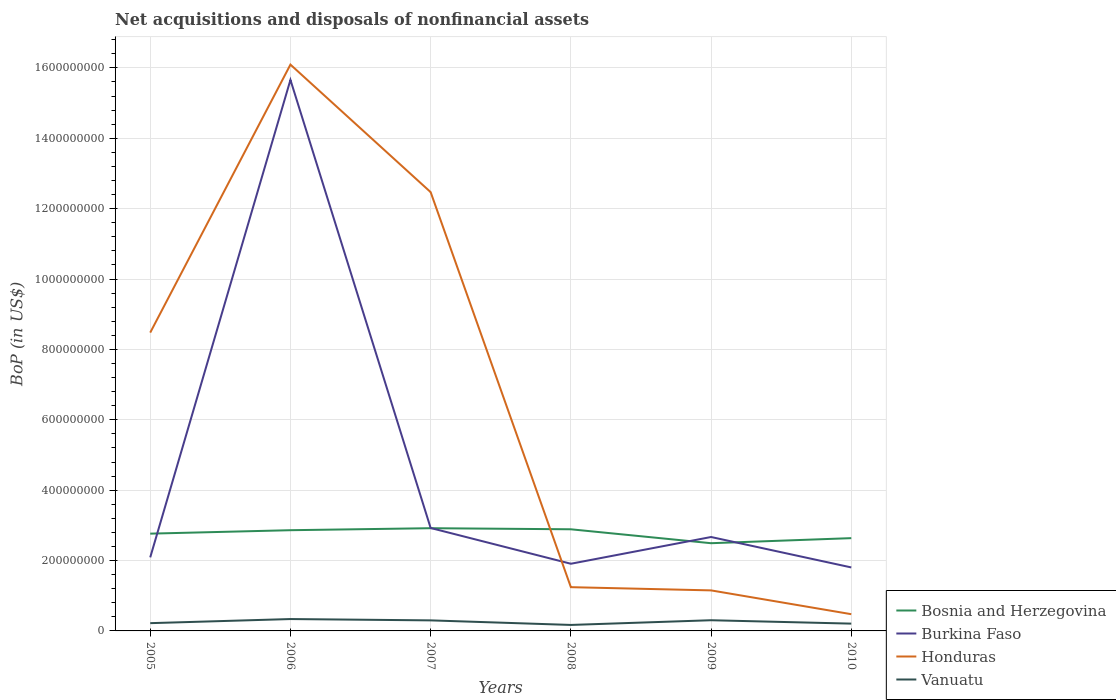How many different coloured lines are there?
Ensure brevity in your answer.  4. Across all years, what is the maximum Balance of Payments in Honduras?
Ensure brevity in your answer.  4.76e+07. What is the total Balance of Payments in Vanuatu in the graph?
Keep it short and to the point. 9.23e+06. What is the difference between the highest and the second highest Balance of Payments in Vanuatu?
Your answer should be very brief. 1.67e+07. What is the difference between the highest and the lowest Balance of Payments in Vanuatu?
Your response must be concise. 3. How many lines are there?
Ensure brevity in your answer.  4. How many years are there in the graph?
Give a very brief answer. 6. Does the graph contain grids?
Keep it short and to the point. Yes. Where does the legend appear in the graph?
Offer a terse response. Bottom right. What is the title of the graph?
Give a very brief answer. Net acquisitions and disposals of nonfinancial assets. Does "Middle East & North Africa (all income levels)" appear as one of the legend labels in the graph?
Ensure brevity in your answer.  No. What is the label or title of the X-axis?
Ensure brevity in your answer.  Years. What is the label or title of the Y-axis?
Offer a terse response. BoP (in US$). What is the BoP (in US$) in Bosnia and Herzegovina in 2005?
Your answer should be compact. 2.76e+08. What is the BoP (in US$) of Burkina Faso in 2005?
Your answer should be compact. 2.09e+08. What is the BoP (in US$) in Honduras in 2005?
Your answer should be compact. 8.48e+08. What is the BoP (in US$) of Vanuatu in 2005?
Make the answer very short. 2.21e+07. What is the BoP (in US$) in Bosnia and Herzegovina in 2006?
Ensure brevity in your answer.  2.86e+08. What is the BoP (in US$) of Burkina Faso in 2006?
Your answer should be very brief. 1.57e+09. What is the BoP (in US$) in Honduras in 2006?
Ensure brevity in your answer.  1.61e+09. What is the BoP (in US$) in Vanuatu in 2006?
Provide a succinct answer. 3.37e+07. What is the BoP (in US$) in Bosnia and Herzegovina in 2007?
Keep it short and to the point. 2.92e+08. What is the BoP (in US$) in Burkina Faso in 2007?
Give a very brief answer. 2.92e+08. What is the BoP (in US$) in Honduras in 2007?
Give a very brief answer. 1.25e+09. What is the BoP (in US$) of Vanuatu in 2007?
Ensure brevity in your answer.  3.00e+07. What is the BoP (in US$) of Bosnia and Herzegovina in 2008?
Make the answer very short. 2.89e+08. What is the BoP (in US$) of Burkina Faso in 2008?
Ensure brevity in your answer.  1.91e+08. What is the BoP (in US$) of Honduras in 2008?
Ensure brevity in your answer.  1.24e+08. What is the BoP (in US$) of Vanuatu in 2008?
Make the answer very short. 1.70e+07. What is the BoP (in US$) in Bosnia and Herzegovina in 2009?
Your answer should be very brief. 2.49e+08. What is the BoP (in US$) of Burkina Faso in 2009?
Provide a short and direct response. 2.67e+08. What is the BoP (in US$) of Honduras in 2009?
Offer a terse response. 1.15e+08. What is the BoP (in US$) of Vanuatu in 2009?
Your response must be concise. 3.04e+07. What is the BoP (in US$) in Bosnia and Herzegovina in 2010?
Keep it short and to the point. 2.64e+08. What is the BoP (in US$) of Burkina Faso in 2010?
Give a very brief answer. 1.80e+08. What is the BoP (in US$) in Honduras in 2010?
Give a very brief answer. 4.76e+07. What is the BoP (in US$) in Vanuatu in 2010?
Your answer should be very brief. 2.07e+07. Across all years, what is the maximum BoP (in US$) of Bosnia and Herzegovina?
Give a very brief answer. 2.92e+08. Across all years, what is the maximum BoP (in US$) of Burkina Faso?
Provide a short and direct response. 1.57e+09. Across all years, what is the maximum BoP (in US$) in Honduras?
Offer a very short reply. 1.61e+09. Across all years, what is the maximum BoP (in US$) of Vanuatu?
Offer a very short reply. 3.37e+07. Across all years, what is the minimum BoP (in US$) of Bosnia and Herzegovina?
Provide a short and direct response. 2.49e+08. Across all years, what is the minimum BoP (in US$) in Burkina Faso?
Ensure brevity in your answer.  1.80e+08. Across all years, what is the minimum BoP (in US$) of Honduras?
Keep it short and to the point. 4.76e+07. Across all years, what is the minimum BoP (in US$) of Vanuatu?
Ensure brevity in your answer.  1.70e+07. What is the total BoP (in US$) in Bosnia and Herzegovina in the graph?
Keep it short and to the point. 1.66e+09. What is the total BoP (in US$) in Burkina Faso in the graph?
Your response must be concise. 2.71e+09. What is the total BoP (in US$) in Honduras in the graph?
Your response must be concise. 3.99e+09. What is the total BoP (in US$) of Vanuatu in the graph?
Your response must be concise. 1.54e+08. What is the difference between the BoP (in US$) in Bosnia and Herzegovina in 2005 and that in 2006?
Make the answer very short. -9.77e+06. What is the difference between the BoP (in US$) in Burkina Faso in 2005 and that in 2006?
Give a very brief answer. -1.36e+09. What is the difference between the BoP (in US$) in Honduras in 2005 and that in 2006?
Your answer should be compact. -7.62e+08. What is the difference between the BoP (in US$) of Vanuatu in 2005 and that in 2006?
Give a very brief answer. -1.17e+07. What is the difference between the BoP (in US$) of Bosnia and Herzegovina in 2005 and that in 2007?
Provide a succinct answer. -1.54e+07. What is the difference between the BoP (in US$) in Burkina Faso in 2005 and that in 2007?
Your answer should be very brief. -8.35e+07. What is the difference between the BoP (in US$) of Honduras in 2005 and that in 2007?
Offer a very short reply. -3.99e+08. What is the difference between the BoP (in US$) of Vanuatu in 2005 and that in 2007?
Your answer should be very brief. -7.89e+06. What is the difference between the BoP (in US$) of Bosnia and Herzegovina in 2005 and that in 2008?
Offer a very short reply. -1.24e+07. What is the difference between the BoP (in US$) in Burkina Faso in 2005 and that in 2008?
Ensure brevity in your answer.  1.81e+07. What is the difference between the BoP (in US$) in Honduras in 2005 and that in 2008?
Provide a short and direct response. 7.23e+08. What is the difference between the BoP (in US$) of Vanuatu in 2005 and that in 2008?
Your response must be concise. 5.06e+06. What is the difference between the BoP (in US$) in Bosnia and Herzegovina in 2005 and that in 2009?
Give a very brief answer. 2.72e+07. What is the difference between the BoP (in US$) in Burkina Faso in 2005 and that in 2009?
Provide a short and direct response. -5.79e+07. What is the difference between the BoP (in US$) of Honduras in 2005 and that in 2009?
Ensure brevity in your answer.  7.33e+08. What is the difference between the BoP (in US$) of Vanuatu in 2005 and that in 2009?
Give a very brief answer. -8.30e+06. What is the difference between the BoP (in US$) of Bosnia and Herzegovina in 2005 and that in 2010?
Offer a very short reply. 1.28e+07. What is the difference between the BoP (in US$) of Burkina Faso in 2005 and that in 2010?
Your response must be concise. 2.86e+07. What is the difference between the BoP (in US$) of Honduras in 2005 and that in 2010?
Your response must be concise. 8.00e+08. What is the difference between the BoP (in US$) in Vanuatu in 2005 and that in 2010?
Keep it short and to the point. 1.34e+06. What is the difference between the BoP (in US$) of Bosnia and Herzegovina in 2006 and that in 2007?
Your answer should be compact. -5.67e+06. What is the difference between the BoP (in US$) in Burkina Faso in 2006 and that in 2007?
Your answer should be compact. 1.27e+09. What is the difference between the BoP (in US$) in Honduras in 2006 and that in 2007?
Provide a succinct answer. 3.62e+08. What is the difference between the BoP (in US$) in Vanuatu in 2006 and that in 2007?
Make the answer very short. 3.78e+06. What is the difference between the BoP (in US$) in Bosnia and Herzegovina in 2006 and that in 2008?
Provide a short and direct response. -2.60e+06. What is the difference between the BoP (in US$) in Burkina Faso in 2006 and that in 2008?
Offer a very short reply. 1.37e+09. What is the difference between the BoP (in US$) in Honduras in 2006 and that in 2008?
Give a very brief answer. 1.48e+09. What is the difference between the BoP (in US$) in Vanuatu in 2006 and that in 2008?
Provide a short and direct response. 1.67e+07. What is the difference between the BoP (in US$) of Bosnia and Herzegovina in 2006 and that in 2009?
Keep it short and to the point. 3.70e+07. What is the difference between the BoP (in US$) in Burkina Faso in 2006 and that in 2009?
Your answer should be very brief. 1.30e+09. What is the difference between the BoP (in US$) in Honduras in 2006 and that in 2009?
Offer a terse response. 1.49e+09. What is the difference between the BoP (in US$) of Vanuatu in 2006 and that in 2009?
Your answer should be compact. 3.37e+06. What is the difference between the BoP (in US$) in Bosnia and Herzegovina in 2006 and that in 2010?
Keep it short and to the point. 2.25e+07. What is the difference between the BoP (in US$) of Burkina Faso in 2006 and that in 2010?
Offer a terse response. 1.39e+09. What is the difference between the BoP (in US$) in Honduras in 2006 and that in 2010?
Make the answer very short. 1.56e+09. What is the difference between the BoP (in US$) of Vanuatu in 2006 and that in 2010?
Ensure brevity in your answer.  1.30e+07. What is the difference between the BoP (in US$) of Bosnia and Herzegovina in 2007 and that in 2008?
Your answer should be very brief. 3.07e+06. What is the difference between the BoP (in US$) in Burkina Faso in 2007 and that in 2008?
Make the answer very short. 1.02e+08. What is the difference between the BoP (in US$) in Honduras in 2007 and that in 2008?
Keep it short and to the point. 1.12e+09. What is the difference between the BoP (in US$) in Vanuatu in 2007 and that in 2008?
Keep it short and to the point. 1.30e+07. What is the difference between the BoP (in US$) of Bosnia and Herzegovina in 2007 and that in 2009?
Offer a terse response. 4.26e+07. What is the difference between the BoP (in US$) in Burkina Faso in 2007 and that in 2009?
Your answer should be very brief. 2.56e+07. What is the difference between the BoP (in US$) of Honduras in 2007 and that in 2009?
Keep it short and to the point. 1.13e+09. What is the difference between the BoP (in US$) of Vanuatu in 2007 and that in 2009?
Keep it short and to the point. -4.10e+05. What is the difference between the BoP (in US$) of Bosnia and Herzegovina in 2007 and that in 2010?
Your answer should be very brief. 2.82e+07. What is the difference between the BoP (in US$) in Burkina Faso in 2007 and that in 2010?
Keep it short and to the point. 1.12e+08. What is the difference between the BoP (in US$) of Honduras in 2007 and that in 2010?
Your response must be concise. 1.20e+09. What is the difference between the BoP (in US$) in Vanuatu in 2007 and that in 2010?
Offer a very short reply. 9.23e+06. What is the difference between the BoP (in US$) of Bosnia and Herzegovina in 2008 and that in 2009?
Provide a short and direct response. 3.96e+07. What is the difference between the BoP (in US$) in Burkina Faso in 2008 and that in 2009?
Your answer should be compact. -7.60e+07. What is the difference between the BoP (in US$) in Honduras in 2008 and that in 2009?
Provide a succinct answer. 9.15e+06. What is the difference between the BoP (in US$) in Vanuatu in 2008 and that in 2009?
Your answer should be compact. -1.34e+07. What is the difference between the BoP (in US$) in Bosnia and Herzegovina in 2008 and that in 2010?
Keep it short and to the point. 2.51e+07. What is the difference between the BoP (in US$) of Burkina Faso in 2008 and that in 2010?
Keep it short and to the point. 1.05e+07. What is the difference between the BoP (in US$) in Honduras in 2008 and that in 2010?
Your answer should be very brief. 7.68e+07. What is the difference between the BoP (in US$) in Vanuatu in 2008 and that in 2010?
Give a very brief answer. -3.72e+06. What is the difference between the BoP (in US$) in Bosnia and Herzegovina in 2009 and that in 2010?
Provide a succinct answer. -1.44e+07. What is the difference between the BoP (in US$) in Burkina Faso in 2009 and that in 2010?
Ensure brevity in your answer.  8.64e+07. What is the difference between the BoP (in US$) in Honduras in 2009 and that in 2010?
Offer a very short reply. 6.76e+07. What is the difference between the BoP (in US$) of Vanuatu in 2009 and that in 2010?
Offer a very short reply. 9.64e+06. What is the difference between the BoP (in US$) in Bosnia and Herzegovina in 2005 and the BoP (in US$) in Burkina Faso in 2006?
Your answer should be compact. -1.29e+09. What is the difference between the BoP (in US$) in Bosnia and Herzegovina in 2005 and the BoP (in US$) in Honduras in 2006?
Your response must be concise. -1.33e+09. What is the difference between the BoP (in US$) of Bosnia and Herzegovina in 2005 and the BoP (in US$) of Vanuatu in 2006?
Make the answer very short. 2.43e+08. What is the difference between the BoP (in US$) in Burkina Faso in 2005 and the BoP (in US$) in Honduras in 2006?
Make the answer very short. -1.40e+09. What is the difference between the BoP (in US$) of Burkina Faso in 2005 and the BoP (in US$) of Vanuatu in 2006?
Provide a short and direct response. 1.75e+08. What is the difference between the BoP (in US$) in Honduras in 2005 and the BoP (in US$) in Vanuatu in 2006?
Offer a terse response. 8.14e+08. What is the difference between the BoP (in US$) in Bosnia and Herzegovina in 2005 and the BoP (in US$) in Burkina Faso in 2007?
Keep it short and to the point. -1.60e+07. What is the difference between the BoP (in US$) in Bosnia and Herzegovina in 2005 and the BoP (in US$) in Honduras in 2007?
Your answer should be very brief. -9.70e+08. What is the difference between the BoP (in US$) of Bosnia and Herzegovina in 2005 and the BoP (in US$) of Vanuatu in 2007?
Your answer should be very brief. 2.46e+08. What is the difference between the BoP (in US$) of Burkina Faso in 2005 and the BoP (in US$) of Honduras in 2007?
Keep it short and to the point. -1.04e+09. What is the difference between the BoP (in US$) of Burkina Faso in 2005 and the BoP (in US$) of Vanuatu in 2007?
Keep it short and to the point. 1.79e+08. What is the difference between the BoP (in US$) in Honduras in 2005 and the BoP (in US$) in Vanuatu in 2007?
Make the answer very short. 8.18e+08. What is the difference between the BoP (in US$) in Bosnia and Herzegovina in 2005 and the BoP (in US$) in Burkina Faso in 2008?
Provide a short and direct response. 8.56e+07. What is the difference between the BoP (in US$) in Bosnia and Herzegovina in 2005 and the BoP (in US$) in Honduras in 2008?
Offer a terse response. 1.52e+08. What is the difference between the BoP (in US$) in Bosnia and Herzegovina in 2005 and the BoP (in US$) in Vanuatu in 2008?
Your answer should be compact. 2.59e+08. What is the difference between the BoP (in US$) of Burkina Faso in 2005 and the BoP (in US$) of Honduras in 2008?
Make the answer very short. 8.47e+07. What is the difference between the BoP (in US$) in Burkina Faso in 2005 and the BoP (in US$) in Vanuatu in 2008?
Offer a very short reply. 1.92e+08. What is the difference between the BoP (in US$) of Honduras in 2005 and the BoP (in US$) of Vanuatu in 2008?
Make the answer very short. 8.31e+08. What is the difference between the BoP (in US$) of Bosnia and Herzegovina in 2005 and the BoP (in US$) of Burkina Faso in 2009?
Your response must be concise. 9.57e+06. What is the difference between the BoP (in US$) in Bosnia and Herzegovina in 2005 and the BoP (in US$) in Honduras in 2009?
Offer a terse response. 1.61e+08. What is the difference between the BoP (in US$) of Bosnia and Herzegovina in 2005 and the BoP (in US$) of Vanuatu in 2009?
Provide a short and direct response. 2.46e+08. What is the difference between the BoP (in US$) of Burkina Faso in 2005 and the BoP (in US$) of Honduras in 2009?
Keep it short and to the point. 9.38e+07. What is the difference between the BoP (in US$) of Burkina Faso in 2005 and the BoP (in US$) of Vanuatu in 2009?
Provide a short and direct response. 1.79e+08. What is the difference between the BoP (in US$) in Honduras in 2005 and the BoP (in US$) in Vanuatu in 2009?
Provide a short and direct response. 8.17e+08. What is the difference between the BoP (in US$) of Bosnia and Herzegovina in 2005 and the BoP (in US$) of Burkina Faso in 2010?
Give a very brief answer. 9.60e+07. What is the difference between the BoP (in US$) in Bosnia and Herzegovina in 2005 and the BoP (in US$) in Honduras in 2010?
Make the answer very short. 2.29e+08. What is the difference between the BoP (in US$) in Bosnia and Herzegovina in 2005 and the BoP (in US$) in Vanuatu in 2010?
Provide a succinct answer. 2.56e+08. What is the difference between the BoP (in US$) in Burkina Faso in 2005 and the BoP (in US$) in Honduras in 2010?
Provide a short and direct response. 1.61e+08. What is the difference between the BoP (in US$) in Burkina Faso in 2005 and the BoP (in US$) in Vanuatu in 2010?
Your response must be concise. 1.88e+08. What is the difference between the BoP (in US$) in Honduras in 2005 and the BoP (in US$) in Vanuatu in 2010?
Ensure brevity in your answer.  8.27e+08. What is the difference between the BoP (in US$) in Bosnia and Herzegovina in 2006 and the BoP (in US$) in Burkina Faso in 2007?
Your answer should be very brief. -6.27e+06. What is the difference between the BoP (in US$) of Bosnia and Herzegovina in 2006 and the BoP (in US$) of Honduras in 2007?
Offer a terse response. -9.61e+08. What is the difference between the BoP (in US$) of Bosnia and Herzegovina in 2006 and the BoP (in US$) of Vanuatu in 2007?
Provide a succinct answer. 2.56e+08. What is the difference between the BoP (in US$) of Burkina Faso in 2006 and the BoP (in US$) of Honduras in 2007?
Keep it short and to the point. 3.19e+08. What is the difference between the BoP (in US$) in Burkina Faso in 2006 and the BoP (in US$) in Vanuatu in 2007?
Your answer should be compact. 1.54e+09. What is the difference between the BoP (in US$) in Honduras in 2006 and the BoP (in US$) in Vanuatu in 2007?
Offer a very short reply. 1.58e+09. What is the difference between the BoP (in US$) of Bosnia and Herzegovina in 2006 and the BoP (in US$) of Burkina Faso in 2008?
Your answer should be compact. 9.53e+07. What is the difference between the BoP (in US$) of Bosnia and Herzegovina in 2006 and the BoP (in US$) of Honduras in 2008?
Your answer should be compact. 1.62e+08. What is the difference between the BoP (in US$) of Bosnia and Herzegovina in 2006 and the BoP (in US$) of Vanuatu in 2008?
Keep it short and to the point. 2.69e+08. What is the difference between the BoP (in US$) of Burkina Faso in 2006 and the BoP (in US$) of Honduras in 2008?
Ensure brevity in your answer.  1.44e+09. What is the difference between the BoP (in US$) in Burkina Faso in 2006 and the BoP (in US$) in Vanuatu in 2008?
Give a very brief answer. 1.55e+09. What is the difference between the BoP (in US$) in Honduras in 2006 and the BoP (in US$) in Vanuatu in 2008?
Ensure brevity in your answer.  1.59e+09. What is the difference between the BoP (in US$) of Bosnia and Herzegovina in 2006 and the BoP (in US$) of Burkina Faso in 2009?
Ensure brevity in your answer.  1.93e+07. What is the difference between the BoP (in US$) in Bosnia and Herzegovina in 2006 and the BoP (in US$) in Honduras in 2009?
Your response must be concise. 1.71e+08. What is the difference between the BoP (in US$) in Bosnia and Herzegovina in 2006 and the BoP (in US$) in Vanuatu in 2009?
Offer a terse response. 2.56e+08. What is the difference between the BoP (in US$) of Burkina Faso in 2006 and the BoP (in US$) of Honduras in 2009?
Make the answer very short. 1.45e+09. What is the difference between the BoP (in US$) of Burkina Faso in 2006 and the BoP (in US$) of Vanuatu in 2009?
Keep it short and to the point. 1.54e+09. What is the difference between the BoP (in US$) in Honduras in 2006 and the BoP (in US$) in Vanuatu in 2009?
Provide a short and direct response. 1.58e+09. What is the difference between the BoP (in US$) of Bosnia and Herzegovina in 2006 and the BoP (in US$) of Burkina Faso in 2010?
Provide a short and direct response. 1.06e+08. What is the difference between the BoP (in US$) of Bosnia and Herzegovina in 2006 and the BoP (in US$) of Honduras in 2010?
Your answer should be compact. 2.39e+08. What is the difference between the BoP (in US$) in Bosnia and Herzegovina in 2006 and the BoP (in US$) in Vanuatu in 2010?
Ensure brevity in your answer.  2.65e+08. What is the difference between the BoP (in US$) in Burkina Faso in 2006 and the BoP (in US$) in Honduras in 2010?
Ensure brevity in your answer.  1.52e+09. What is the difference between the BoP (in US$) of Burkina Faso in 2006 and the BoP (in US$) of Vanuatu in 2010?
Provide a succinct answer. 1.55e+09. What is the difference between the BoP (in US$) of Honduras in 2006 and the BoP (in US$) of Vanuatu in 2010?
Ensure brevity in your answer.  1.59e+09. What is the difference between the BoP (in US$) of Bosnia and Herzegovina in 2007 and the BoP (in US$) of Burkina Faso in 2008?
Keep it short and to the point. 1.01e+08. What is the difference between the BoP (in US$) of Bosnia and Herzegovina in 2007 and the BoP (in US$) of Honduras in 2008?
Give a very brief answer. 1.68e+08. What is the difference between the BoP (in US$) of Bosnia and Herzegovina in 2007 and the BoP (in US$) of Vanuatu in 2008?
Offer a terse response. 2.75e+08. What is the difference between the BoP (in US$) in Burkina Faso in 2007 and the BoP (in US$) in Honduras in 2008?
Ensure brevity in your answer.  1.68e+08. What is the difference between the BoP (in US$) in Burkina Faso in 2007 and the BoP (in US$) in Vanuatu in 2008?
Keep it short and to the point. 2.75e+08. What is the difference between the BoP (in US$) of Honduras in 2007 and the BoP (in US$) of Vanuatu in 2008?
Make the answer very short. 1.23e+09. What is the difference between the BoP (in US$) in Bosnia and Herzegovina in 2007 and the BoP (in US$) in Burkina Faso in 2009?
Offer a very short reply. 2.50e+07. What is the difference between the BoP (in US$) of Bosnia and Herzegovina in 2007 and the BoP (in US$) of Honduras in 2009?
Make the answer very short. 1.77e+08. What is the difference between the BoP (in US$) of Bosnia and Herzegovina in 2007 and the BoP (in US$) of Vanuatu in 2009?
Provide a succinct answer. 2.62e+08. What is the difference between the BoP (in US$) in Burkina Faso in 2007 and the BoP (in US$) in Honduras in 2009?
Offer a very short reply. 1.77e+08. What is the difference between the BoP (in US$) of Burkina Faso in 2007 and the BoP (in US$) of Vanuatu in 2009?
Give a very brief answer. 2.62e+08. What is the difference between the BoP (in US$) in Honduras in 2007 and the BoP (in US$) in Vanuatu in 2009?
Your answer should be very brief. 1.22e+09. What is the difference between the BoP (in US$) of Bosnia and Herzegovina in 2007 and the BoP (in US$) of Burkina Faso in 2010?
Provide a short and direct response. 1.11e+08. What is the difference between the BoP (in US$) of Bosnia and Herzegovina in 2007 and the BoP (in US$) of Honduras in 2010?
Offer a very short reply. 2.44e+08. What is the difference between the BoP (in US$) in Bosnia and Herzegovina in 2007 and the BoP (in US$) in Vanuatu in 2010?
Your response must be concise. 2.71e+08. What is the difference between the BoP (in US$) of Burkina Faso in 2007 and the BoP (in US$) of Honduras in 2010?
Your answer should be very brief. 2.45e+08. What is the difference between the BoP (in US$) in Burkina Faso in 2007 and the BoP (in US$) in Vanuatu in 2010?
Your response must be concise. 2.72e+08. What is the difference between the BoP (in US$) of Honduras in 2007 and the BoP (in US$) of Vanuatu in 2010?
Offer a very short reply. 1.23e+09. What is the difference between the BoP (in US$) of Bosnia and Herzegovina in 2008 and the BoP (in US$) of Burkina Faso in 2009?
Offer a terse response. 2.19e+07. What is the difference between the BoP (in US$) of Bosnia and Herzegovina in 2008 and the BoP (in US$) of Honduras in 2009?
Offer a very short reply. 1.74e+08. What is the difference between the BoP (in US$) of Bosnia and Herzegovina in 2008 and the BoP (in US$) of Vanuatu in 2009?
Give a very brief answer. 2.58e+08. What is the difference between the BoP (in US$) of Burkina Faso in 2008 and the BoP (in US$) of Honduras in 2009?
Offer a terse response. 7.57e+07. What is the difference between the BoP (in US$) in Burkina Faso in 2008 and the BoP (in US$) in Vanuatu in 2009?
Offer a terse response. 1.60e+08. What is the difference between the BoP (in US$) of Honduras in 2008 and the BoP (in US$) of Vanuatu in 2009?
Ensure brevity in your answer.  9.40e+07. What is the difference between the BoP (in US$) of Bosnia and Herzegovina in 2008 and the BoP (in US$) of Burkina Faso in 2010?
Ensure brevity in your answer.  1.08e+08. What is the difference between the BoP (in US$) of Bosnia and Herzegovina in 2008 and the BoP (in US$) of Honduras in 2010?
Your response must be concise. 2.41e+08. What is the difference between the BoP (in US$) of Bosnia and Herzegovina in 2008 and the BoP (in US$) of Vanuatu in 2010?
Provide a short and direct response. 2.68e+08. What is the difference between the BoP (in US$) of Burkina Faso in 2008 and the BoP (in US$) of Honduras in 2010?
Offer a very short reply. 1.43e+08. What is the difference between the BoP (in US$) of Burkina Faso in 2008 and the BoP (in US$) of Vanuatu in 2010?
Your answer should be compact. 1.70e+08. What is the difference between the BoP (in US$) of Honduras in 2008 and the BoP (in US$) of Vanuatu in 2010?
Your answer should be very brief. 1.04e+08. What is the difference between the BoP (in US$) in Bosnia and Herzegovina in 2009 and the BoP (in US$) in Burkina Faso in 2010?
Offer a very short reply. 6.88e+07. What is the difference between the BoP (in US$) of Bosnia and Herzegovina in 2009 and the BoP (in US$) of Honduras in 2010?
Keep it short and to the point. 2.02e+08. What is the difference between the BoP (in US$) in Bosnia and Herzegovina in 2009 and the BoP (in US$) in Vanuatu in 2010?
Your answer should be very brief. 2.29e+08. What is the difference between the BoP (in US$) in Burkina Faso in 2009 and the BoP (in US$) in Honduras in 2010?
Provide a short and direct response. 2.19e+08. What is the difference between the BoP (in US$) in Burkina Faso in 2009 and the BoP (in US$) in Vanuatu in 2010?
Provide a short and direct response. 2.46e+08. What is the difference between the BoP (in US$) of Honduras in 2009 and the BoP (in US$) of Vanuatu in 2010?
Your answer should be compact. 9.45e+07. What is the average BoP (in US$) in Bosnia and Herzegovina per year?
Your response must be concise. 2.76e+08. What is the average BoP (in US$) of Burkina Faso per year?
Keep it short and to the point. 4.51e+08. What is the average BoP (in US$) in Honduras per year?
Your response must be concise. 6.65e+08. What is the average BoP (in US$) of Vanuatu per year?
Make the answer very short. 2.56e+07. In the year 2005, what is the difference between the BoP (in US$) in Bosnia and Herzegovina and BoP (in US$) in Burkina Faso?
Provide a succinct answer. 6.74e+07. In the year 2005, what is the difference between the BoP (in US$) of Bosnia and Herzegovina and BoP (in US$) of Honduras?
Your answer should be compact. -5.71e+08. In the year 2005, what is the difference between the BoP (in US$) in Bosnia and Herzegovina and BoP (in US$) in Vanuatu?
Give a very brief answer. 2.54e+08. In the year 2005, what is the difference between the BoP (in US$) in Burkina Faso and BoP (in US$) in Honduras?
Provide a short and direct response. -6.39e+08. In the year 2005, what is the difference between the BoP (in US$) of Burkina Faso and BoP (in US$) of Vanuatu?
Your response must be concise. 1.87e+08. In the year 2005, what is the difference between the BoP (in US$) in Honduras and BoP (in US$) in Vanuatu?
Your response must be concise. 8.26e+08. In the year 2006, what is the difference between the BoP (in US$) in Bosnia and Herzegovina and BoP (in US$) in Burkina Faso?
Keep it short and to the point. -1.28e+09. In the year 2006, what is the difference between the BoP (in US$) in Bosnia and Herzegovina and BoP (in US$) in Honduras?
Provide a succinct answer. -1.32e+09. In the year 2006, what is the difference between the BoP (in US$) in Bosnia and Herzegovina and BoP (in US$) in Vanuatu?
Offer a very short reply. 2.52e+08. In the year 2006, what is the difference between the BoP (in US$) of Burkina Faso and BoP (in US$) of Honduras?
Keep it short and to the point. -4.35e+07. In the year 2006, what is the difference between the BoP (in US$) of Burkina Faso and BoP (in US$) of Vanuatu?
Keep it short and to the point. 1.53e+09. In the year 2006, what is the difference between the BoP (in US$) of Honduras and BoP (in US$) of Vanuatu?
Keep it short and to the point. 1.58e+09. In the year 2007, what is the difference between the BoP (in US$) in Bosnia and Herzegovina and BoP (in US$) in Burkina Faso?
Give a very brief answer. -5.97e+05. In the year 2007, what is the difference between the BoP (in US$) of Bosnia and Herzegovina and BoP (in US$) of Honduras?
Your answer should be very brief. -9.55e+08. In the year 2007, what is the difference between the BoP (in US$) of Bosnia and Herzegovina and BoP (in US$) of Vanuatu?
Offer a very short reply. 2.62e+08. In the year 2007, what is the difference between the BoP (in US$) of Burkina Faso and BoP (in US$) of Honduras?
Offer a very short reply. -9.54e+08. In the year 2007, what is the difference between the BoP (in US$) in Burkina Faso and BoP (in US$) in Vanuatu?
Make the answer very short. 2.63e+08. In the year 2007, what is the difference between the BoP (in US$) in Honduras and BoP (in US$) in Vanuatu?
Provide a succinct answer. 1.22e+09. In the year 2008, what is the difference between the BoP (in US$) in Bosnia and Herzegovina and BoP (in US$) in Burkina Faso?
Your answer should be very brief. 9.79e+07. In the year 2008, what is the difference between the BoP (in US$) in Bosnia and Herzegovina and BoP (in US$) in Honduras?
Your answer should be very brief. 1.64e+08. In the year 2008, what is the difference between the BoP (in US$) in Bosnia and Herzegovina and BoP (in US$) in Vanuatu?
Provide a short and direct response. 2.72e+08. In the year 2008, what is the difference between the BoP (in US$) of Burkina Faso and BoP (in US$) of Honduras?
Give a very brief answer. 6.65e+07. In the year 2008, what is the difference between the BoP (in US$) of Burkina Faso and BoP (in US$) of Vanuatu?
Your answer should be very brief. 1.74e+08. In the year 2008, what is the difference between the BoP (in US$) in Honduras and BoP (in US$) in Vanuatu?
Make the answer very short. 1.07e+08. In the year 2009, what is the difference between the BoP (in US$) of Bosnia and Herzegovina and BoP (in US$) of Burkina Faso?
Provide a succinct answer. -1.76e+07. In the year 2009, what is the difference between the BoP (in US$) of Bosnia and Herzegovina and BoP (in US$) of Honduras?
Make the answer very short. 1.34e+08. In the year 2009, what is the difference between the BoP (in US$) in Bosnia and Herzegovina and BoP (in US$) in Vanuatu?
Your response must be concise. 2.19e+08. In the year 2009, what is the difference between the BoP (in US$) of Burkina Faso and BoP (in US$) of Honduras?
Provide a succinct answer. 1.52e+08. In the year 2009, what is the difference between the BoP (in US$) in Burkina Faso and BoP (in US$) in Vanuatu?
Your answer should be compact. 2.36e+08. In the year 2009, what is the difference between the BoP (in US$) of Honduras and BoP (in US$) of Vanuatu?
Ensure brevity in your answer.  8.48e+07. In the year 2010, what is the difference between the BoP (in US$) of Bosnia and Herzegovina and BoP (in US$) of Burkina Faso?
Offer a very short reply. 8.32e+07. In the year 2010, what is the difference between the BoP (in US$) in Bosnia and Herzegovina and BoP (in US$) in Honduras?
Provide a short and direct response. 2.16e+08. In the year 2010, what is the difference between the BoP (in US$) in Bosnia and Herzegovina and BoP (in US$) in Vanuatu?
Provide a succinct answer. 2.43e+08. In the year 2010, what is the difference between the BoP (in US$) of Burkina Faso and BoP (in US$) of Honduras?
Provide a succinct answer. 1.33e+08. In the year 2010, what is the difference between the BoP (in US$) of Burkina Faso and BoP (in US$) of Vanuatu?
Offer a terse response. 1.60e+08. In the year 2010, what is the difference between the BoP (in US$) in Honduras and BoP (in US$) in Vanuatu?
Offer a terse response. 2.68e+07. What is the ratio of the BoP (in US$) in Bosnia and Herzegovina in 2005 to that in 2006?
Offer a very short reply. 0.97. What is the ratio of the BoP (in US$) of Burkina Faso in 2005 to that in 2006?
Your answer should be very brief. 0.13. What is the ratio of the BoP (in US$) of Honduras in 2005 to that in 2006?
Your answer should be very brief. 0.53. What is the ratio of the BoP (in US$) of Vanuatu in 2005 to that in 2006?
Provide a succinct answer. 0.65. What is the ratio of the BoP (in US$) of Bosnia and Herzegovina in 2005 to that in 2007?
Your response must be concise. 0.95. What is the ratio of the BoP (in US$) in Burkina Faso in 2005 to that in 2007?
Provide a succinct answer. 0.71. What is the ratio of the BoP (in US$) in Honduras in 2005 to that in 2007?
Offer a terse response. 0.68. What is the ratio of the BoP (in US$) in Vanuatu in 2005 to that in 2007?
Your response must be concise. 0.74. What is the ratio of the BoP (in US$) of Bosnia and Herzegovina in 2005 to that in 2008?
Offer a very short reply. 0.96. What is the ratio of the BoP (in US$) of Burkina Faso in 2005 to that in 2008?
Offer a terse response. 1.1. What is the ratio of the BoP (in US$) of Honduras in 2005 to that in 2008?
Your answer should be compact. 6.82. What is the ratio of the BoP (in US$) in Vanuatu in 2005 to that in 2008?
Give a very brief answer. 1.3. What is the ratio of the BoP (in US$) in Bosnia and Herzegovina in 2005 to that in 2009?
Offer a terse response. 1.11. What is the ratio of the BoP (in US$) of Burkina Faso in 2005 to that in 2009?
Provide a short and direct response. 0.78. What is the ratio of the BoP (in US$) of Honduras in 2005 to that in 2009?
Ensure brevity in your answer.  7.36. What is the ratio of the BoP (in US$) of Vanuatu in 2005 to that in 2009?
Keep it short and to the point. 0.73. What is the ratio of the BoP (in US$) of Bosnia and Herzegovina in 2005 to that in 2010?
Your answer should be very brief. 1.05. What is the ratio of the BoP (in US$) in Burkina Faso in 2005 to that in 2010?
Give a very brief answer. 1.16. What is the ratio of the BoP (in US$) of Honduras in 2005 to that in 2010?
Your answer should be very brief. 17.82. What is the ratio of the BoP (in US$) of Vanuatu in 2005 to that in 2010?
Your answer should be compact. 1.06. What is the ratio of the BoP (in US$) of Bosnia and Herzegovina in 2006 to that in 2007?
Give a very brief answer. 0.98. What is the ratio of the BoP (in US$) in Burkina Faso in 2006 to that in 2007?
Provide a succinct answer. 5.35. What is the ratio of the BoP (in US$) in Honduras in 2006 to that in 2007?
Your answer should be compact. 1.29. What is the ratio of the BoP (in US$) of Vanuatu in 2006 to that in 2007?
Give a very brief answer. 1.13. What is the ratio of the BoP (in US$) of Bosnia and Herzegovina in 2006 to that in 2008?
Keep it short and to the point. 0.99. What is the ratio of the BoP (in US$) of Burkina Faso in 2006 to that in 2008?
Provide a succinct answer. 8.2. What is the ratio of the BoP (in US$) in Honduras in 2006 to that in 2008?
Ensure brevity in your answer.  12.94. What is the ratio of the BoP (in US$) in Vanuatu in 2006 to that in 2008?
Keep it short and to the point. 1.98. What is the ratio of the BoP (in US$) in Bosnia and Herzegovina in 2006 to that in 2009?
Ensure brevity in your answer.  1.15. What is the ratio of the BoP (in US$) of Burkina Faso in 2006 to that in 2009?
Your answer should be compact. 5.87. What is the ratio of the BoP (in US$) of Honduras in 2006 to that in 2009?
Provide a succinct answer. 13.97. What is the ratio of the BoP (in US$) in Vanuatu in 2006 to that in 2009?
Your answer should be very brief. 1.11. What is the ratio of the BoP (in US$) in Bosnia and Herzegovina in 2006 to that in 2010?
Your response must be concise. 1.09. What is the ratio of the BoP (in US$) in Burkina Faso in 2006 to that in 2010?
Offer a very short reply. 8.68. What is the ratio of the BoP (in US$) in Honduras in 2006 to that in 2010?
Provide a succinct answer. 33.83. What is the ratio of the BoP (in US$) in Vanuatu in 2006 to that in 2010?
Keep it short and to the point. 1.63. What is the ratio of the BoP (in US$) in Bosnia and Herzegovina in 2007 to that in 2008?
Make the answer very short. 1.01. What is the ratio of the BoP (in US$) in Burkina Faso in 2007 to that in 2008?
Keep it short and to the point. 1.53. What is the ratio of the BoP (in US$) of Honduras in 2007 to that in 2008?
Ensure brevity in your answer.  10.03. What is the ratio of the BoP (in US$) in Vanuatu in 2007 to that in 2008?
Offer a terse response. 1.76. What is the ratio of the BoP (in US$) in Bosnia and Herzegovina in 2007 to that in 2009?
Provide a succinct answer. 1.17. What is the ratio of the BoP (in US$) of Burkina Faso in 2007 to that in 2009?
Ensure brevity in your answer.  1.1. What is the ratio of the BoP (in US$) in Honduras in 2007 to that in 2009?
Make the answer very short. 10.82. What is the ratio of the BoP (in US$) in Vanuatu in 2007 to that in 2009?
Offer a terse response. 0.99. What is the ratio of the BoP (in US$) of Bosnia and Herzegovina in 2007 to that in 2010?
Your response must be concise. 1.11. What is the ratio of the BoP (in US$) of Burkina Faso in 2007 to that in 2010?
Your answer should be very brief. 1.62. What is the ratio of the BoP (in US$) of Honduras in 2007 to that in 2010?
Your response must be concise. 26.21. What is the ratio of the BoP (in US$) in Vanuatu in 2007 to that in 2010?
Ensure brevity in your answer.  1.45. What is the ratio of the BoP (in US$) in Bosnia and Herzegovina in 2008 to that in 2009?
Your response must be concise. 1.16. What is the ratio of the BoP (in US$) of Burkina Faso in 2008 to that in 2009?
Your response must be concise. 0.72. What is the ratio of the BoP (in US$) of Honduras in 2008 to that in 2009?
Your answer should be compact. 1.08. What is the ratio of the BoP (in US$) in Vanuatu in 2008 to that in 2009?
Offer a terse response. 0.56. What is the ratio of the BoP (in US$) of Bosnia and Herzegovina in 2008 to that in 2010?
Your answer should be very brief. 1.1. What is the ratio of the BoP (in US$) in Burkina Faso in 2008 to that in 2010?
Offer a terse response. 1.06. What is the ratio of the BoP (in US$) in Honduras in 2008 to that in 2010?
Keep it short and to the point. 2.61. What is the ratio of the BoP (in US$) of Vanuatu in 2008 to that in 2010?
Give a very brief answer. 0.82. What is the ratio of the BoP (in US$) in Bosnia and Herzegovina in 2009 to that in 2010?
Give a very brief answer. 0.95. What is the ratio of the BoP (in US$) of Burkina Faso in 2009 to that in 2010?
Make the answer very short. 1.48. What is the ratio of the BoP (in US$) in Honduras in 2009 to that in 2010?
Your response must be concise. 2.42. What is the ratio of the BoP (in US$) of Vanuatu in 2009 to that in 2010?
Keep it short and to the point. 1.47. What is the difference between the highest and the second highest BoP (in US$) in Bosnia and Herzegovina?
Your response must be concise. 3.07e+06. What is the difference between the highest and the second highest BoP (in US$) in Burkina Faso?
Your response must be concise. 1.27e+09. What is the difference between the highest and the second highest BoP (in US$) in Honduras?
Give a very brief answer. 3.62e+08. What is the difference between the highest and the second highest BoP (in US$) of Vanuatu?
Your response must be concise. 3.37e+06. What is the difference between the highest and the lowest BoP (in US$) in Bosnia and Herzegovina?
Your response must be concise. 4.26e+07. What is the difference between the highest and the lowest BoP (in US$) of Burkina Faso?
Keep it short and to the point. 1.39e+09. What is the difference between the highest and the lowest BoP (in US$) in Honduras?
Give a very brief answer. 1.56e+09. What is the difference between the highest and the lowest BoP (in US$) in Vanuatu?
Provide a succinct answer. 1.67e+07. 